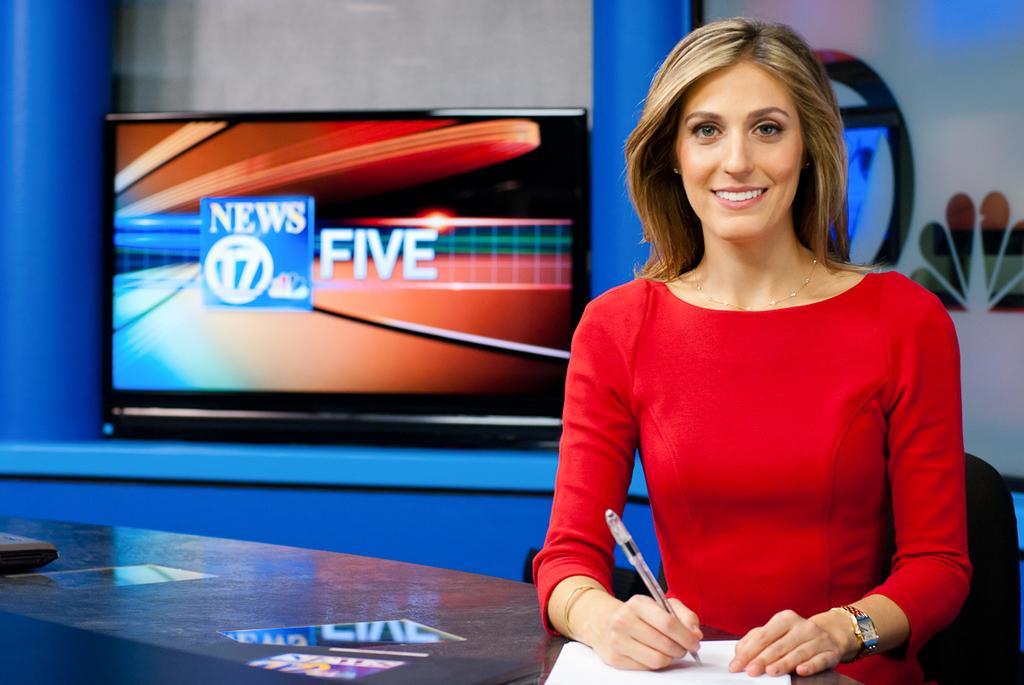Describe this image in one or two sentences. In this image I see a woman who is smiling and she is holding a paper and there is a paper in front of her. In the background I see the television. 